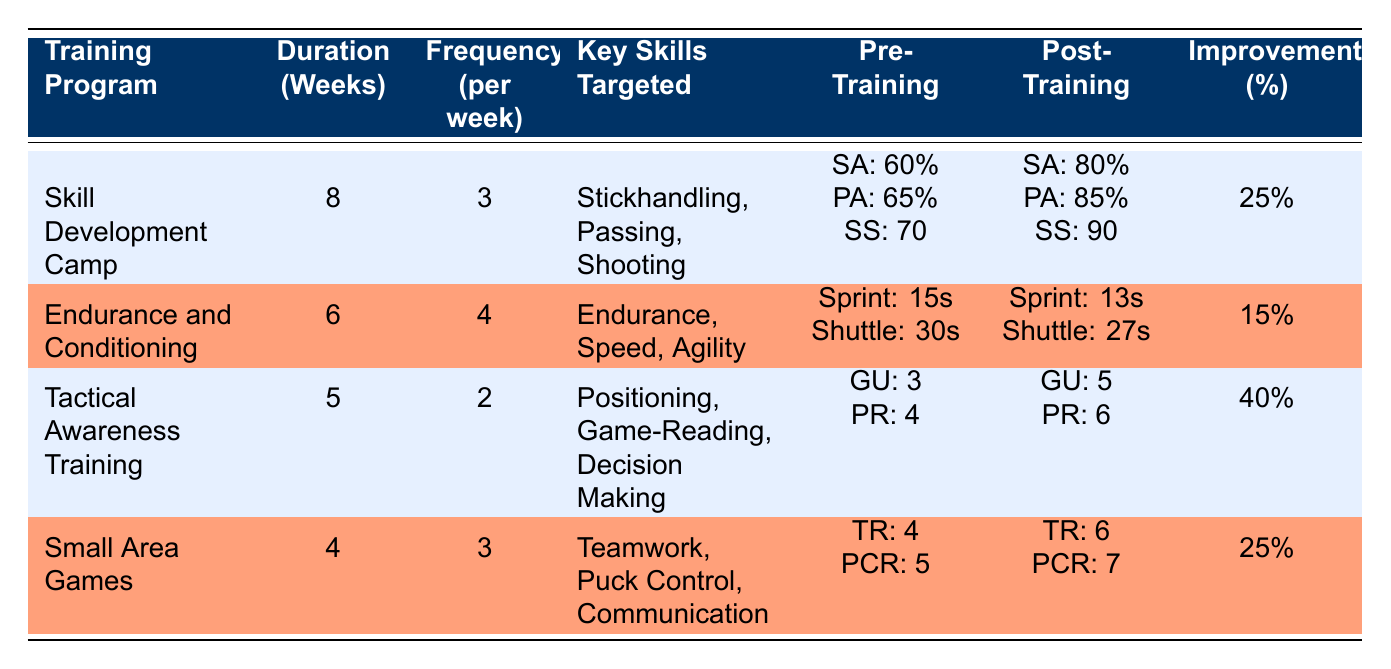What is the overall skill improvement percentage for the Tactical Awareness Training program? The Tactical Awareness Training program has an overall skill improvement percentage of 40%, which is stated clearly in the last column of the table next to the corresponding program.
Answer: 40% How many weeks did the Skill Development Camp last? The Skill Development Camp lasted for 8 weeks, as indicated in the Duration (Weeks) column of the table.
Answer: 8 weeks Which training program targeted teamwork as a key skill? The Small Area Games training program targeted teamwork, which is listed under Key Skills Targeted for that particular program in the table.
Answer: Small Area Games What was the pre-training shooting accuracy score for the Skill Development Camp program? The pre-training shooting accuracy score for the Skill Development Camp program was 60%, found in the Pre-Training column of the table.
Answer: 60% If the Training Program "Endurance and Conditioning" had an improvement percentage of 15%, how much would that result in if the maximum possible improvement percentage was 100%? To find this, we take the maximum improvement (100%) and subtract the actual improvement (15%), resulting in: 100 - 15 = 85. Thus, there is a remaining potential improvement of 85%.
Answer: 85% Did the Tactical Awareness Training program improve the Game Understanding rating? Yes, the Tactical Awareness Training program improved the Game Understanding rating from 3 to 5, which shows an improvement, confirmed by comparing the Pre-Training and Post-Training Assessment values in the table.
Answer: Yes What is the average frequency per week for all training programs combined? To calculate the average frequency, we sum the frequencies (3 + 4 + 2 + 3 = 12) and divide by the number of programs (4). Therefore, the average frequency per week is 12/4 = 3.
Answer: 3 Which program had the highest overall improvement percentage? The Tactical Awareness Training program had the highest overall improvement percentage at 40%, as it is listed as the highest value in the Overall Skill Improvement Percentage column of the table.
Answer: Tactical Awareness Training What was the pre-training shuttle run time for the Endurance and Conditioning program? The pre-training shuttle run time for the Endurance and Conditioning program was 30 seconds, which is found in the Pre-Training Assessment section of the table.
Answer: 30 seconds 